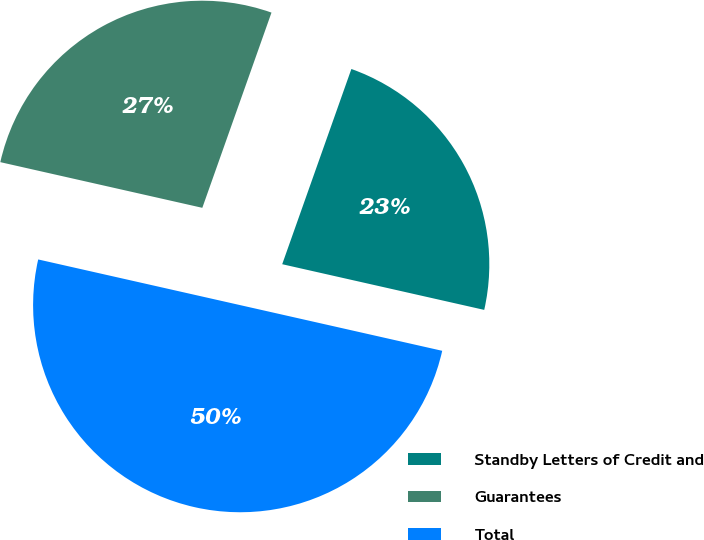Convert chart to OTSL. <chart><loc_0><loc_0><loc_500><loc_500><pie_chart><fcel>Standby Letters of Credit and<fcel>Guarantees<fcel>Total<nl><fcel>23.12%<fcel>26.88%<fcel>50.0%<nl></chart> 